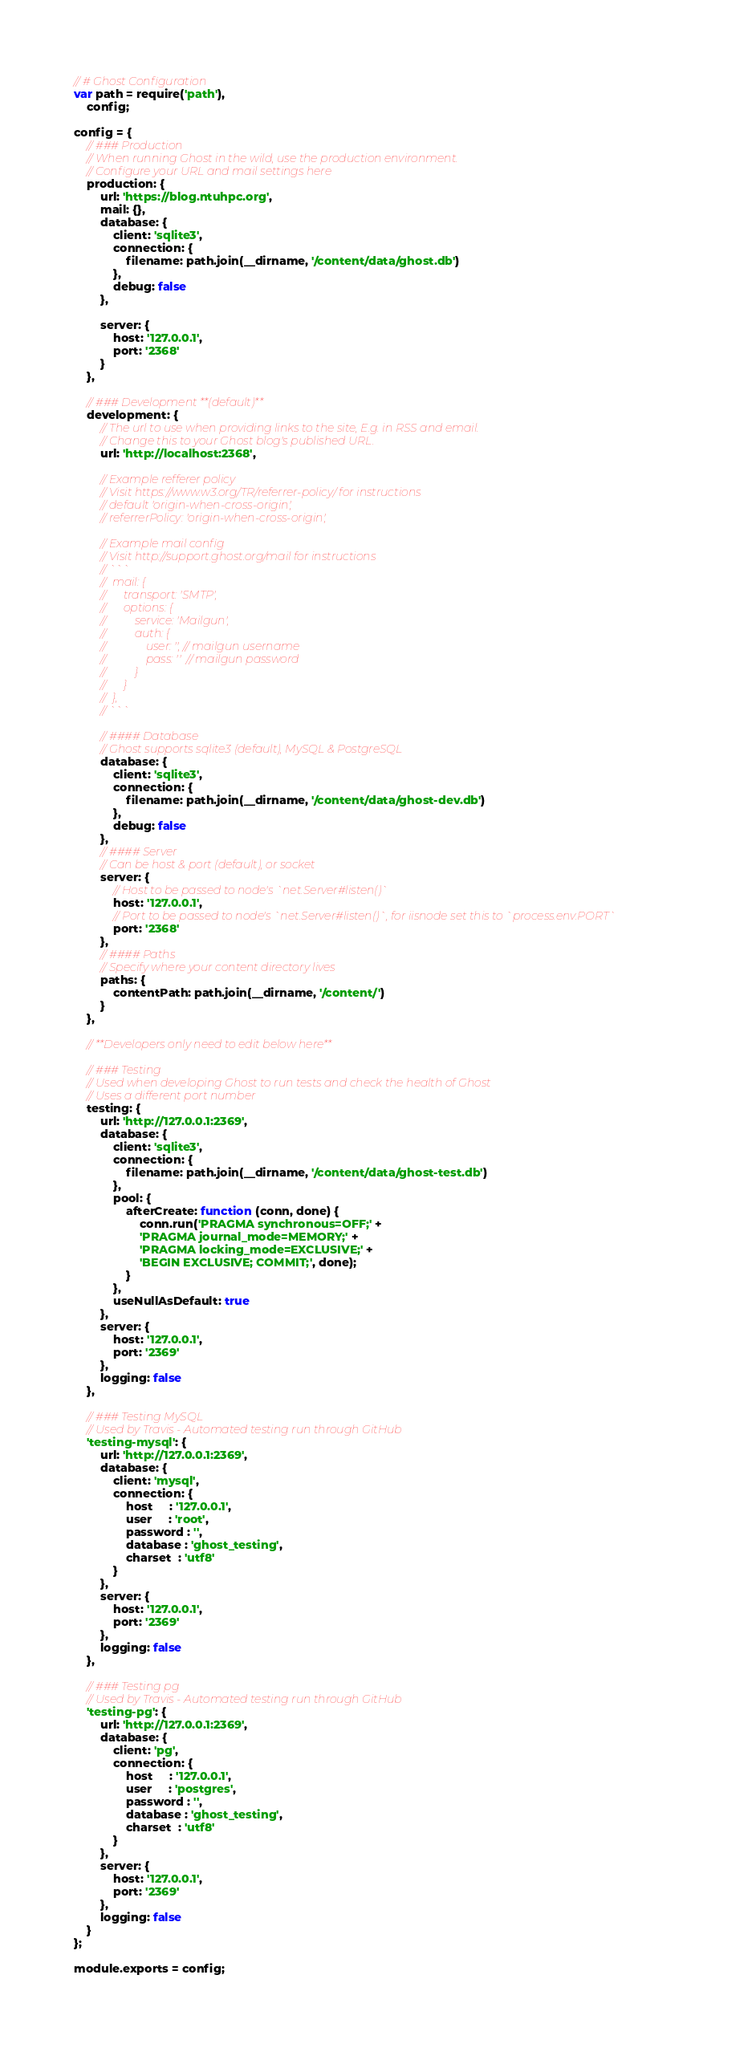Convert code to text. <code><loc_0><loc_0><loc_500><loc_500><_JavaScript_>// # Ghost Configuration
var path = require('path'),
    config;

config = {
    // ### Production
    // When running Ghost in the wild, use the production environment.
    // Configure your URL and mail settings here
    production: {
        url: 'https://blog.ntuhpc.org',
        mail: {},
        database: {
            client: 'sqlite3',
            connection: {
                filename: path.join(__dirname, '/content/data/ghost.db')
            },
            debug: false
        },

        server: {
            host: '127.0.0.1',
            port: '2368'
        }
    },

    // ### Development **(default)**
    development: {
        // The url to use when providing links to the site, E.g. in RSS and email.
        // Change this to your Ghost blog's published URL.
        url: 'http://localhost:2368',

        // Example refferer policy
        // Visit https://www.w3.org/TR/referrer-policy/ for instructions
        // default 'origin-when-cross-origin',
        // referrerPolicy: 'origin-when-cross-origin',

        // Example mail config
        // Visit http://support.ghost.org/mail for instructions
        // ```
        //  mail: {
        //      transport: 'SMTP',
        //      options: {
        //          service: 'Mailgun',
        //          auth: {
        //              user: '', // mailgun username
        //              pass: ''  // mailgun password
        //          }
        //      }
        //  },
        // ```

        // #### Database
        // Ghost supports sqlite3 (default), MySQL & PostgreSQL
        database: {
            client: 'sqlite3',
            connection: {
                filename: path.join(__dirname, '/content/data/ghost-dev.db')
            },
            debug: false
        },
        // #### Server
        // Can be host & port (default), or socket
        server: {
            // Host to be passed to node's `net.Server#listen()`
            host: '127.0.0.1',
            // Port to be passed to node's `net.Server#listen()`, for iisnode set this to `process.env.PORT`
            port: '2368'
        },
        // #### Paths
        // Specify where your content directory lives
        paths: {
            contentPath: path.join(__dirname, '/content/')
        }
    },

    // **Developers only need to edit below here**

    // ### Testing
    // Used when developing Ghost to run tests and check the health of Ghost
    // Uses a different port number
    testing: {
        url: 'http://127.0.0.1:2369',
        database: {
            client: 'sqlite3',
            connection: {
                filename: path.join(__dirname, '/content/data/ghost-test.db')
            },
            pool: {
                afterCreate: function (conn, done) {
                    conn.run('PRAGMA synchronous=OFF;' +
                    'PRAGMA journal_mode=MEMORY;' +
                    'PRAGMA locking_mode=EXCLUSIVE;' +
                    'BEGIN EXCLUSIVE; COMMIT;', done);
                }
            },
            useNullAsDefault: true
        },
        server: {
            host: '127.0.0.1',
            port: '2369'
        },
        logging: false
    },

    // ### Testing MySQL
    // Used by Travis - Automated testing run through GitHub
    'testing-mysql': {
        url: 'http://127.0.0.1:2369',
        database: {
            client: 'mysql',
            connection: {
                host     : '127.0.0.1',
                user     : 'root',
                password : '',
                database : 'ghost_testing',
                charset  : 'utf8'
            }
        },
        server: {
            host: '127.0.0.1',
            port: '2369'
        },
        logging: false
    },

    // ### Testing pg
    // Used by Travis - Automated testing run through GitHub
    'testing-pg': {
        url: 'http://127.0.0.1:2369',
        database: {
            client: 'pg',
            connection: {
                host     : '127.0.0.1',
                user     : 'postgres',
                password : '',
                database : 'ghost_testing',
                charset  : 'utf8'
            }
        },
        server: {
            host: '127.0.0.1',
            port: '2369'
        },
        logging: false
    }
};

module.exports = config;
</code> 